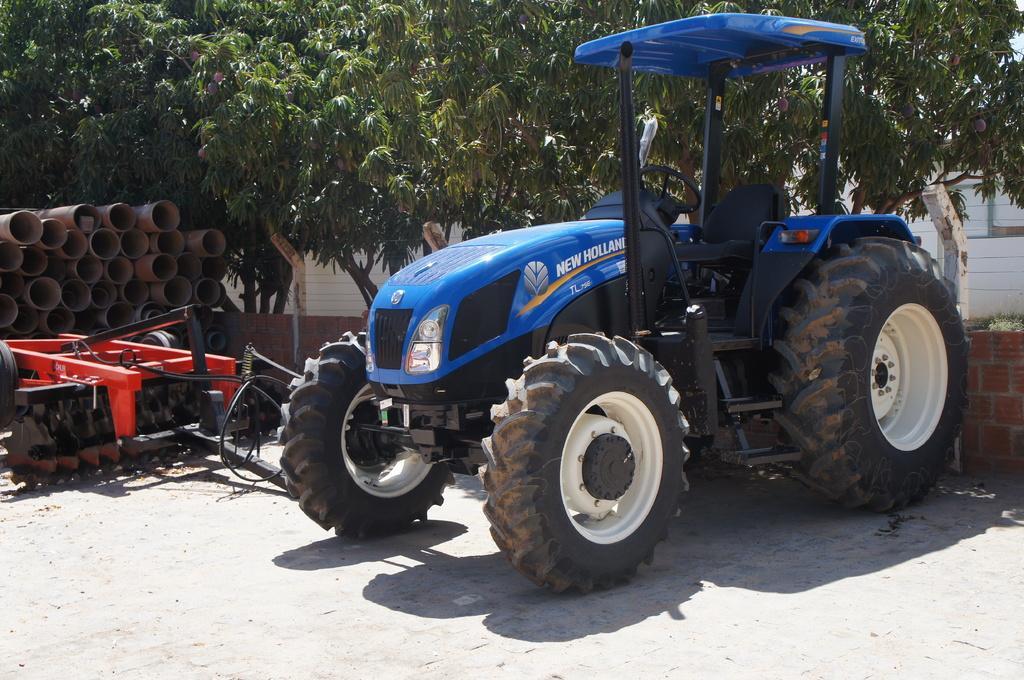Can you describe this image briefly? In this image we can see a tracker. Near to the track there is a brick wall. Also we can see some other object. And there are pipes. In the back there are trees with fruits. 